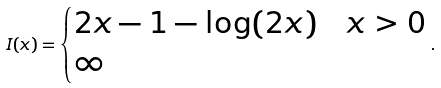Convert formula to latex. <formula><loc_0><loc_0><loc_500><loc_500>I ( x ) = \begin{cases} 2 x - 1 - \log ( 2 x ) & x > 0 \\ \infty & \end{cases} .</formula> 